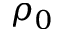<formula> <loc_0><loc_0><loc_500><loc_500>\rho _ { 0 }</formula> 